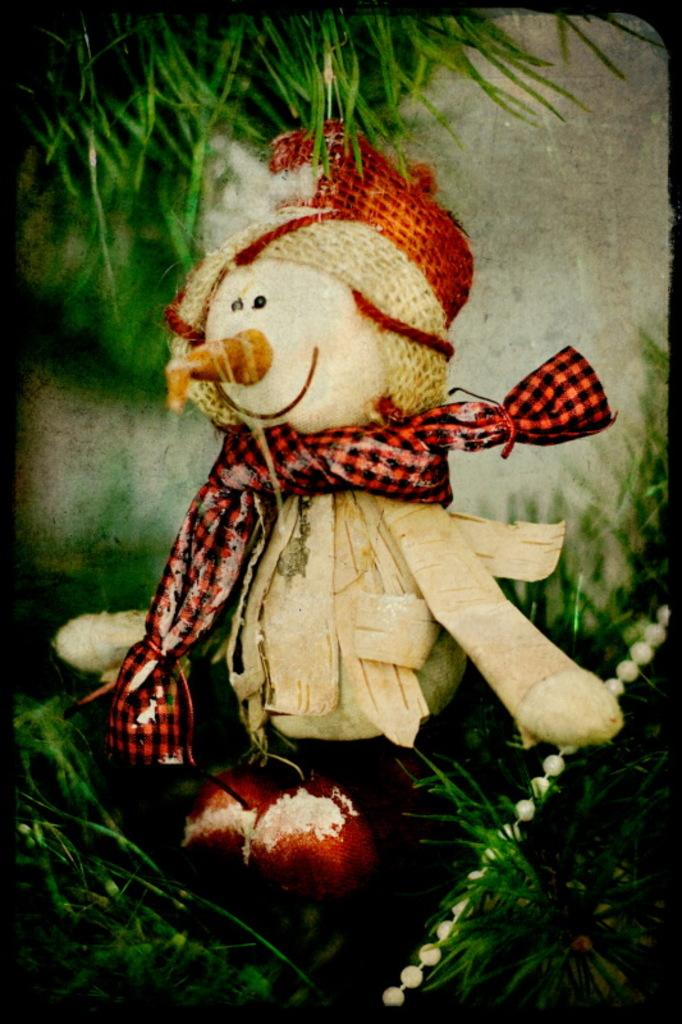What object in the image is designed for play? There is a toy in the image. What type of natural environment is depicted in the image? There is grass in the image. What type of cake is being eaten by the toy in the image? There is no cake present in the image, and the toy is not shown eating anything. What part of the body is the toy using to hold the neck in the image? There is no neck present in the image, and the toy is not shown interacting with any object or person in that manner. 